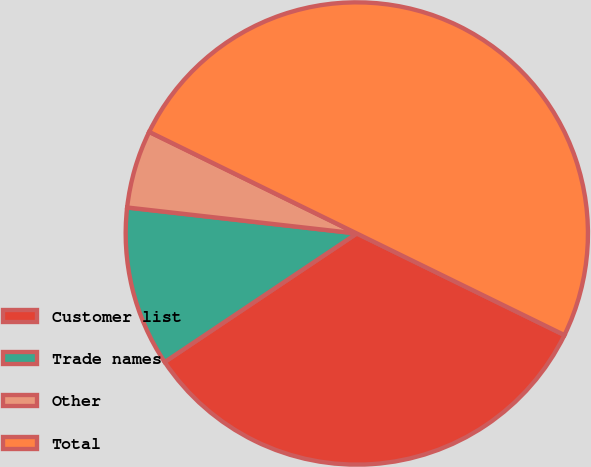Convert chart to OTSL. <chart><loc_0><loc_0><loc_500><loc_500><pie_chart><fcel>Customer list<fcel>Trade names<fcel>Other<fcel>Total<nl><fcel>33.37%<fcel>11.18%<fcel>5.45%<fcel>50.0%<nl></chart> 